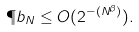Convert formula to latex. <formula><loc_0><loc_0><loc_500><loc_500>\P b _ { N } \leq O ( 2 ^ { - ( N ^ { \beta } ) } ) .</formula> 